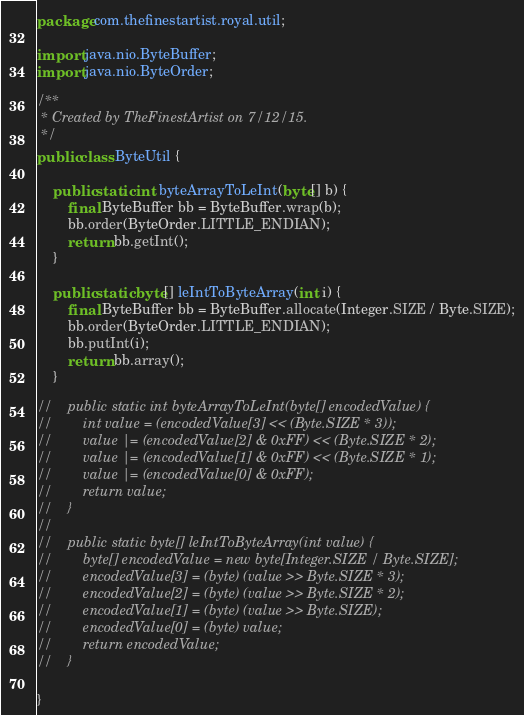Convert code to text. <code><loc_0><loc_0><loc_500><loc_500><_Java_>package com.thefinestartist.royal.util;

import java.nio.ByteBuffer;
import java.nio.ByteOrder;

/**
 * Created by TheFinestArtist on 7/12/15.
 */
public class ByteUtil {

    public static int byteArrayToLeInt(byte[] b) {
        final ByteBuffer bb = ByteBuffer.wrap(b);
        bb.order(ByteOrder.LITTLE_ENDIAN);
        return bb.getInt();
    }

    public static byte[] leIntToByteArray(int i) {
        final ByteBuffer bb = ByteBuffer.allocate(Integer.SIZE / Byte.SIZE);
        bb.order(ByteOrder.LITTLE_ENDIAN);
        bb.putInt(i);
        return bb.array();
    }

//    public static int byteArrayToLeInt(byte[] encodedValue) {
//        int value = (encodedValue[3] << (Byte.SIZE * 3));
//        value |= (encodedValue[2] & 0xFF) << (Byte.SIZE * 2);
//        value |= (encodedValue[1] & 0xFF) << (Byte.SIZE * 1);
//        value |= (encodedValue[0] & 0xFF);
//        return value;
//    }
//
//    public static byte[] leIntToByteArray(int value) {
//        byte[] encodedValue = new byte[Integer.SIZE / Byte.SIZE];
//        encodedValue[3] = (byte) (value >> Byte.SIZE * 3);
//        encodedValue[2] = (byte) (value >> Byte.SIZE * 2);
//        encodedValue[1] = (byte) (value >> Byte.SIZE);
//        encodedValue[0] = (byte) value;
//        return encodedValue;
//    }

}
</code> 